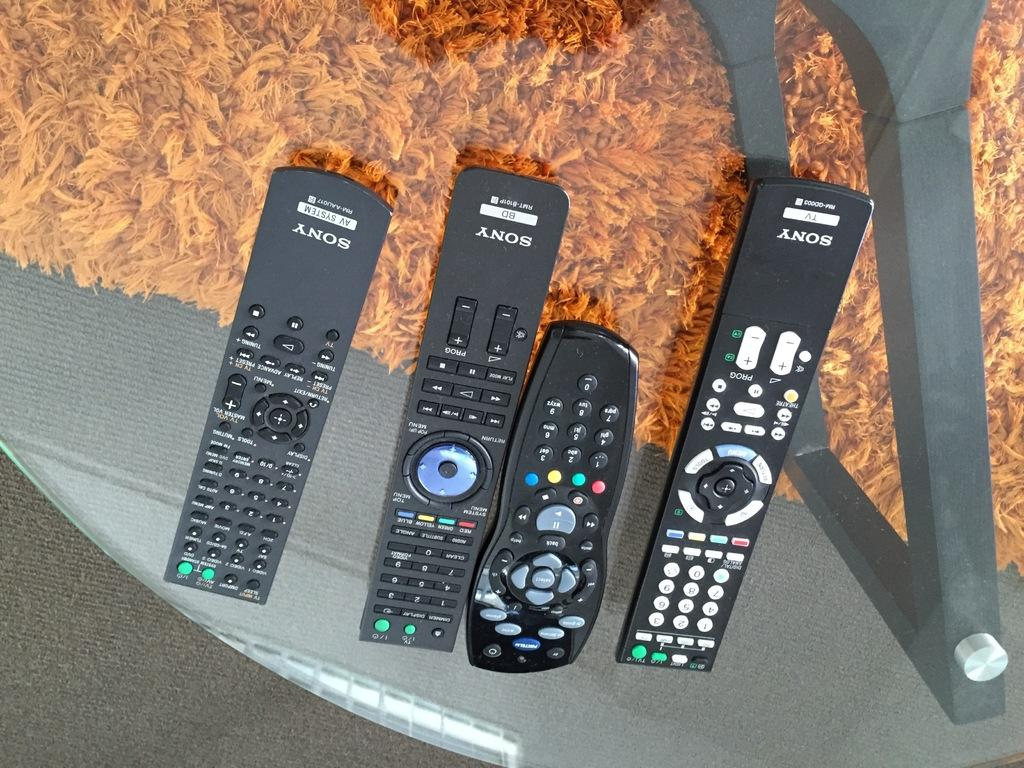<image>
Give a short and clear explanation of the subsequent image. Four remote controls with the sony brand on them resting on a glass surface. 